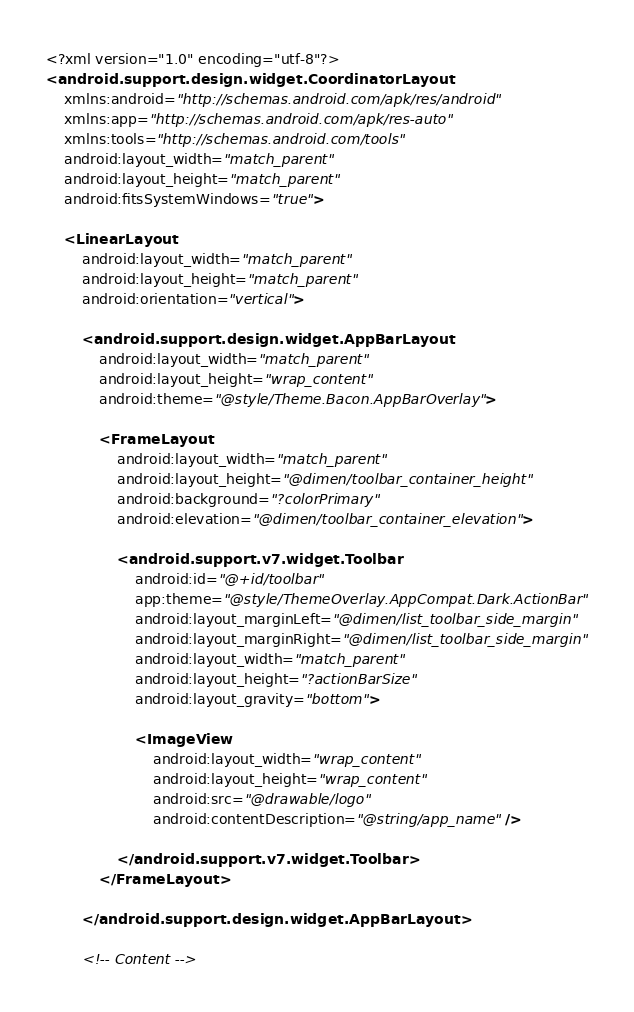<code> <loc_0><loc_0><loc_500><loc_500><_XML_><?xml version="1.0" encoding="utf-8"?>
<android.support.design.widget.CoordinatorLayout
    xmlns:android="http://schemas.android.com/apk/res/android"
    xmlns:app="http://schemas.android.com/apk/res-auto"
    xmlns:tools="http://schemas.android.com/tools"
    android:layout_width="match_parent"
    android:layout_height="match_parent"
    android:fitsSystemWindows="true">

    <LinearLayout
        android:layout_width="match_parent"
        android:layout_height="match_parent"
        android:orientation="vertical">

        <android.support.design.widget.AppBarLayout
            android:layout_width="match_parent"
            android:layout_height="wrap_content"
            android:theme="@style/Theme.Bacon.AppBarOverlay">

            <FrameLayout
                android:layout_width="match_parent"
                android:layout_height="@dimen/toolbar_container_height"
                android:background="?colorPrimary"
                android:elevation="@dimen/toolbar_container_elevation">

                <android.support.v7.widget.Toolbar
                    android:id="@+id/toolbar"
                    app:theme="@style/ThemeOverlay.AppCompat.Dark.ActionBar"
                    android:layout_marginLeft="@dimen/list_toolbar_side_margin"
                    android:layout_marginRight="@dimen/list_toolbar_side_margin"
                    android:layout_width="match_parent"
                    android:layout_height="?actionBarSize"
                    android:layout_gravity="bottom">

                    <ImageView
                        android:layout_width="wrap_content"
                        android:layout_height="wrap_content"
                        android:src="@drawable/logo"
                        android:contentDescription="@string/app_name" />

                </android.support.v7.widget.Toolbar>
            </FrameLayout>

        </android.support.design.widget.AppBarLayout>

        <!-- Content --></code> 